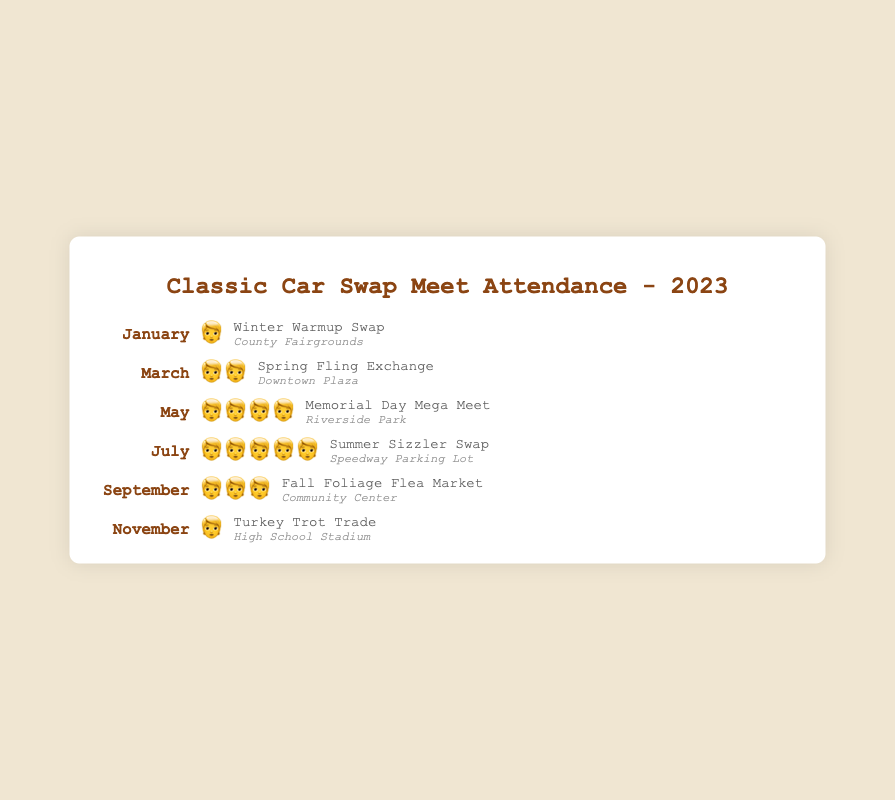Which month has the highest attendance for swap meets? Refer to the attendance count in the figure for each month. The month of July has the most attendance, represented by five people emojis.
Answer: July Which month has the lowest attendance? Compare the attendance levels across all months. Both January and November have the lowest attendance, each represented by one person emoji.
Answer: January and November What is the average attendance emoji count per event? Sum the attendance emojis for all events and divide by the number of events: (1+2+4+5+3+1) ÷ 6 = 16 ÷ 6 ≈ 2.67 emojis.
Answer: 2.67 Which events happen at the Riverside Park location, and what is their attendance? Identify the event held at Riverside Park and its corresponding attendance. The Memorial Day Mega Meet in May has four people emojis.
Answer: Memorial Day Mega Meet, 4 Which event occurred at the Community Center, and how many people attended? Locate the event at the Community Center and count the attendance emojis. The Fall Foliage Flea Market in September has three people emojis.
Answer: Fall Foliage Flea Market, 3 How does attendance in March compare to attendance in September? Compare the attendance emojis of March (two people emojis) against that of September (three people emojis). September has one more person emoji than March.
Answer: September has 1 more Which location hosted the event with the highest attendance? Identify the location of the event in July, which has the highest attendance of five people emojis. The event (Summer Sizzler Swap) was held at Speedway Parking Lot.
Answer: Speedway Parking Lot What is the combined attendance for the Winter Warmup Swap and the Turkey Trot Trade? Sum the attendance of the Winter Warmup Swap (January, one emoji) and the Turkey Trot Trade (November, one emoji): 1+1 = 2.
Answer: 2 Which event in May had the highest attendance, and where was it held? Identify the event, its location, and compare attendance if May had multiple events. The Memorial Day Mega Meet held at Riverside Park has the highest attendance of four people emojis.
Answer: Memorial Day Mega Meet, Riverside Park 